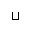<formula> <loc_0><loc_0><loc_500><loc_500>\sqcup</formula> 